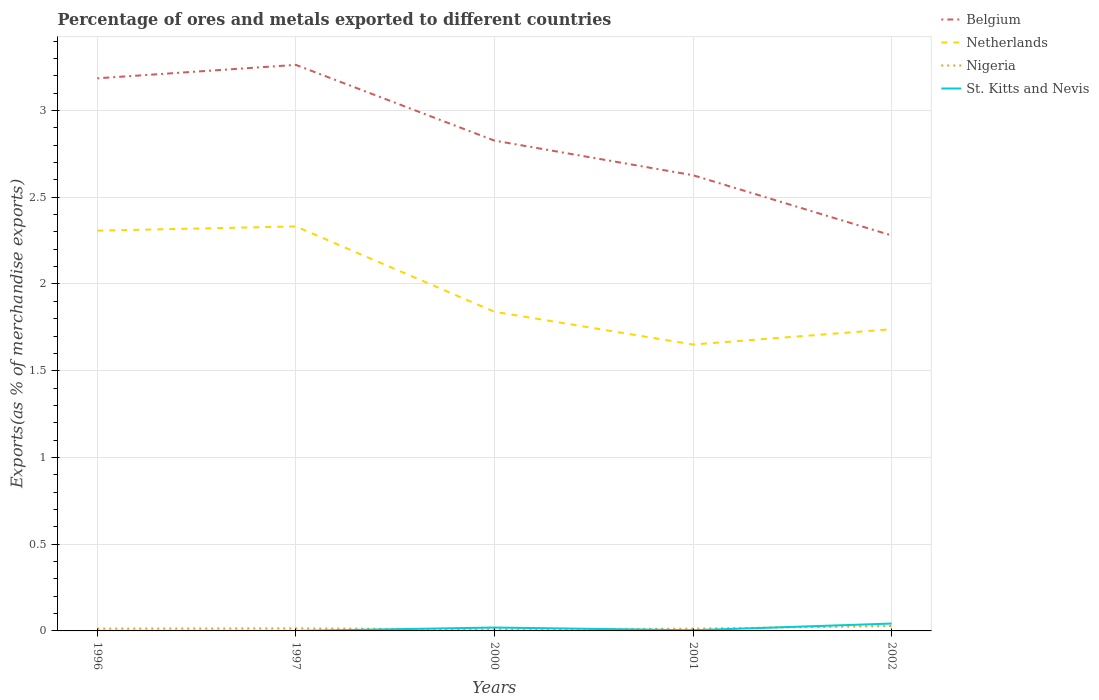Is the number of lines equal to the number of legend labels?
Offer a very short reply. Yes. Across all years, what is the maximum percentage of exports to different countries in Netherlands?
Your response must be concise. 1.65. What is the total percentage of exports to different countries in Nigeria in the graph?
Offer a terse response. -0.02. What is the difference between the highest and the second highest percentage of exports to different countries in St. Kitts and Nevis?
Give a very brief answer. 0.04. Is the percentage of exports to different countries in Netherlands strictly greater than the percentage of exports to different countries in St. Kitts and Nevis over the years?
Offer a very short reply. No. How many lines are there?
Provide a short and direct response. 4. What is the difference between two consecutive major ticks on the Y-axis?
Provide a short and direct response. 0.5. Are the values on the major ticks of Y-axis written in scientific E-notation?
Your response must be concise. No. Does the graph contain any zero values?
Ensure brevity in your answer.  No. Does the graph contain grids?
Make the answer very short. Yes. How many legend labels are there?
Keep it short and to the point. 4. How are the legend labels stacked?
Your response must be concise. Vertical. What is the title of the graph?
Make the answer very short. Percentage of ores and metals exported to different countries. What is the label or title of the Y-axis?
Provide a succinct answer. Exports(as % of merchandise exports). What is the Exports(as % of merchandise exports) in Belgium in 1996?
Your response must be concise. 3.19. What is the Exports(as % of merchandise exports) of Netherlands in 1996?
Keep it short and to the point. 2.31. What is the Exports(as % of merchandise exports) in Nigeria in 1996?
Give a very brief answer. 0.01. What is the Exports(as % of merchandise exports) in St. Kitts and Nevis in 1996?
Give a very brief answer. 0. What is the Exports(as % of merchandise exports) of Belgium in 1997?
Provide a succinct answer. 3.26. What is the Exports(as % of merchandise exports) of Netherlands in 1997?
Give a very brief answer. 2.33. What is the Exports(as % of merchandise exports) in Nigeria in 1997?
Provide a short and direct response. 0.01. What is the Exports(as % of merchandise exports) in St. Kitts and Nevis in 1997?
Your answer should be very brief. 0. What is the Exports(as % of merchandise exports) of Belgium in 2000?
Your response must be concise. 2.83. What is the Exports(as % of merchandise exports) of Netherlands in 2000?
Offer a very short reply. 1.84. What is the Exports(as % of merchandise exports) of Nigeria in 2000?
Provide a succinct answer. 0.01. What is the Exports(as % of merchandise exports) of St. Kitts and Nevis in 2000?
Give a very brief answer. 0.02. What is the Exports(as % of merchandise exports) of Belgium in 2001?
Ensure brevity in your answer.  2.63. What is the Exports(as % of merchandise exports) of Netherlands in 2001?
Provide a short and direct response. 1.65. What is the Exports(as % of merchandise exports) of Nigeria in 2001?
Give a very brief answer. 0.01. What is the Exports(as % of merchandise exports) of St. Kitts and Nevis in 2001?
Your response must be concise. 0. What is the Exports(as % of merchandise exports) in Belgium in 2002?
Your response must be concise. 2.28. What is the Exports(as % of merchandise exports) of Netherlands in 2002?
Ensure brevity in your answer.  1.74. What is the Exports(as % of merchandise exports) in Nigeria in 2002?
Provide a short and direct response. 0.03. What is the Exports(as % of merchandise exports) in St. Kitts and Nevis in 2002?
Your answer should be very brief. 0.04. Across all years, what is the maximum Exports(as % of merchandise exports) of Belgium?
Provide a succinct answer. 3.26. Across all years, what is the maximum Exports(as % of merchandise exports) of Netherlands?
Ensure brevity in your answer.  2.33. Across all years, what is the maximum Exports(as % of merchandise exports) of Nigeria?
Give a very brief answer. 0.03. Across all years, what is the maximum Exports(as % of merchandise exports) in St. Kitts and Nevis?
Provide a short and direct response. 0.04. Across all years, what is the minimum Exports(as % of merchandise exports) in Belgium?
Keep it short and to the point. 2.28. Across all years, what is the minimum Exports(as % of merchandise exports) of Netherlands?
Your answer should be very brief. 1.65. Across all years, what is the minimum Exports(as % of merchandise exports) in Nigeria?
Offer a very short reply. 0.01. Across all years, what is the minimum Exports(as % of merchandise exports) in St. Kitts and Nevis?
Provide a short and direct response. 0. What is the total Exports(as % of merchandise exports) in Belgium in the graph?
Provide a succinct answer. 14.18. What is the total Exports(as % of merchandise exports) of Netherlands in the graph?
Keep it short and to the point. 9.87. What is the total Exports(as % of merchandise exports) in Nigeria in the graph?
Provide a succinct answer. 0.08. What is the total Exports(as % of merchandise exports) in St. Kitts and Nevis in the graph?
Your response must be concise. 0.07. What is the difference between the Exports(as % of merchandise exports) in Belgium in 1996 and that in 1997?
Your answer should be very brief. -0.08. What is the difference between the Exports(as % of merchandise exports) of Netherlands in 1996 and that in 1997?
Your answer should be very brief. -0.02. What is the difference between the Exports(as % of merchandise exports) of Nigeria in 1996 and that in 1997?
Provide a short and direct response. -0. What is the difference between the Exports(as % of merchandise exports) of Belgium in 1996 and that in 2000?
Offer a very short reply. 0.36. What is the difference between the Exports(as % of merchandise exports) of Netherlands in 1996 and that in 2000?
Offer a terse response. 0.47. What is the difference between the Exports(as % of merchandise exports) of Nigeria in 1996 and that in 2000?
Your answer should be very brief. 0. What is the difference between the Exports(as % of merchandise exports) in St. Kitts and Nevis in 1996 and that in 2000?
Offer a terse response. -0.02. What is the difference between the Exports(as % of merchandise exports) of Belgium in 1996 and that in 2001?
Offer a terse response. 0.56. What is the difference between the Exports(as % of merchandise exports) in Netherlands in 1996 and that in 2001?
Offer a terse response. 0.66. What is the difference between the Exports(as % of merchandise exports) of Nigeria in 1996 and that in 2001?
Keep it short and to the point. 0. What is the difference between the Exports(as % of merchandise exports) of St. Kitts and Nevis in 1996 and that in 2001?
Your response must be concise. -0. What is the difference between the Exports(as % of merchandise exports) in Belgium in 1996 and that in 2002?
Provide a short and direct response. 0.91. What is the difference between the Exports(as % of merchandise exports) in Netherlands in 1996 and that in 2002?
Your response must be concise. 0.57. What is the difference between the Exports(as % of merchandise exports) in Nigeria in 1996 and that in 2002?
Give a very brief answer. -0.02. What is the difference between the Exports(as % of merchandise exports) in St. Kitts and Nevis in 1996 and that in 2002?
Your answer should be compact. -0.04. What is the difference between the Exports(as % of merchandise exports) of Belgium in 1997 and that in 2000?
Ensure brevity in your answer.  0.44. What is the difference between the Exports(as % of merchandise exports) in Netherlands in 1997 and that in 2000?
Make the answer very short. 0.49. What is the difference between the Exports(as % of merchandise exports) in Nigeria in 1997 and that in 2000?
Ensure brevity in your answer.  0.01. What is the difference between the Exports(as % of merchandise exports) in St. Kitts and Nevis in 1997 and that in 2000?
Offer a terse response. -0.02. What is the difference between the Exports(as % of merchandise exports) in Belgium in 1997 and that in 2001?
Ensure brevity in your answer.  0.64. What is the difference between the Exports(as % of merchandise exports) in Netherlands in 1997 and that in 2001?
Provide a succinct answer. 0.68. What is the difference between the Exports(as % of merchandise exports) of Nigeria in 1997 and that in 2001?
Your answer should be very brief. 0. What is the difference between the Exports(as % of merchandise exports) of St. Kitts and Nevis in 1997 and that in 2001?
Offer a terse response. -0. What is the difference between the Exports(as % of merchandise exports) of Belgium in 1997 and that in 2002?
Give a very brief answer. 0.98. What is the difference between the Exports(as % of merchandise exports) in Netherlands in 1997 and that in 2002?
Give a very brief answer. 0.59. What is the difference between the Exports(as % of merchandise exports) of Nigeria in 1997 and that in 2002?
Keep it short and to the point. -0.01. What is the difference between the Exports(as % of merchandise exports) in St. Kitts and Nevis in 1997 and that in 2002?
Offer a very short reply. -0.04. What is the difference between the Exports(as % of merchandise exports) of Belgium in 2000 and that in 2001?
Ensure brevity in your answer.  0.2. What is the difference between the Exports(as % of merchandise exports) in Netherlands in 2000 and that in 2001?
Provide a succinct answer. 0.19. What is the difference between the Exports(as % of merchandise exports) of Nigeria in 2000 and that in 2001?
Offer a terse response. -0. What is the difference between the Exports(as % of merchandise exports) of St. Kitts and Nevis in 2000 and that in 2001?
Provide a succinct answer. 0.02. What is the difference between the Exports(as % of merchandise exports) of Belgium in 2000 and that in 2002?
Provide a short and direct response. 0.55. What is the difference between the Exports(as % of merchandise exports) in Netherlands in 2000 and that in 2002?
Provide a succinct answer. 0.1. What is the difference between the Exports(as % of merchandise exports) in Nigeria in 2000 and that in 2002?
Your answer should be compact. -0.02. What is the difference between the Exports(as % of merchandise exports) in St. Kitts and Nevis in 2000 and that in 2002?
Provide a succinct answer. -0.02. What is the difference between the Exports(as % of merchandise exports) in Belgium in 2001 and that in 2002?
Make the answer very short. 0.35. What is the difference between the Exports(as % of merchandise exports) of Netherlands in 2001 and that in 2002?
Keep it short and to the point. -0.09. What is the difference between the Exports(as % of merchandise exports) of Nigeria in 2001 and that in 2002?
Your answer should be very brief. -0.02. What is the difference between the Exports(as % of merchandise exports) of St. Kitts and Nevis in 2001 and that in 2002?
Your answer should be compact. -0.04. What is the difference between the Exports(as % of merchandise exports) of Belgium in 1996 and the Exports(as % of merchandise exports) of Netherlands in 1997?
Offer a terse response. 0.85. What is the difference between the Exports(as % of merchandise exports) of Belgium in 1996 and the Exports(as % of merchandise exports) of Nigeria in 1997?
Your answer should be very brief. 3.17. What is the difference between the Exports(as % of merchandise exports) in Belgium in 1996 and the Exports(as % of merchandise exports) in St. Kitts and Nevis in 1997?
Offer a terse response. 3.19. What is the difference between the Exports(as % of merchandise exports) in Netherlands in 1996 and the Exports(as % of merchandise exports) in Nigeria in 1997?
Provide a short and direct response. 2.29. What is the difference between the Exports(as % of merchandise exports) of Netherlands in 1996 and the Exports(as % of merchandise exports) of St. Kitts and Nevis in 1997?
Your response must be concise. 2.31. What is the difference between the Exports(as % of merchandise exports) of Nigeria in 1996 and the Exports(as % of merchandise exports) of St. Kitts and Nevis in 1997?
Make the answer very short. 0.01. What is the difference between the Exports(as % of merchandise exports) of Belgium in 1996 and the Exports(as % of merchandise exports) of Netherlands in 2000?
Offer a very short reply. 1.35. What is the difference between the Exports(as % of merchandise exports) in Belgium in 1996 and the Exports(as % of merchandise exports) in Nigeria in 2000?
Your answer should be compact. 3.18. What is the difference between the Exports(as % of merchandise exports) of Belgium in 1996 and the Exports(as % of merchandise exports) of St. Kitts and Nevis in 2000?
Keep it short and to the point. 3.17. What is the difference between the Exports(as % of merchandise exports) of Netherlands in 1996 and the Exports(as % of merchandise exports) of Nigeria in 2000?
Make the answer very short. 2.3. What is the difference between the Exports(as % of merchandise exports) in Netherlands in 1996 and the Exports(as % of merchandise exports) in St. Kitts and Nevis in 2000?
Give a very brief answer. 2.29. What is the difference between the Exports(as % of merchandise exports) in Nigeria in 1996 and the Exports(as % of merchandise exports) in St. Kitts and Nevis in 2000?
Give a very brief answer. -0.01. What is the difference between the Exports(as % of merchandise exports) in Belgium in 1996 and the Exports(as % of merchandise exports) in Netherlands in 2001?
Give a very brief answer. 1.53. What is the difference between the Exports(as % of merchandise exports) of Belgium in 1996 and the Exports(as % of merchandise exports) of Nigeria in 2001?
Your answer should be compact. 3.17. What is the difference between the Exports(as % of merchandise exports) in Belgium in 1996 and the Exports(as % of merchandise exports) in St. Kitts and Nevis in 2001?
Your response must be concise. 3.18. What is the difference between the Exports(as % of merchandise exports) of Netherlands in 1996 and the Exports(as % of merchandise exports) of Nigeria in 2001?
Offer a terse response. 2.29. What is the difference between the Exports(as % of merchandise exports) in Netherlands in 1996 and the Exports(as % of merchandise exports) in St. Kitts and Nevis in 2001?
Provide a short and direct response. 2.3. What is the difference between the Exports(as % of merchandise exports) of Nigeria in 1996 and the Exports(as % of merchandise exports) of St. Kitts and Nevis in 2001?
Make the answer very short. 0.01. What is the difference between the Exports(as % of merchandise exports) of Belgium in 1996 and the Exports(as % of merchandise exports) of Netherlands in 2002?
Your answer should be very brief. 1.45. What is the difference between the Exports(as % of merchandise exports) of Belgium in 1996 and the Exports(as % of merchandise exports) of Nigeria in 2002?
Offer a terse response. 3.16. What is the difference between the Exports(as % of merchandise exports) of Belgium in 1996 and the Exports(as % of merchandise exports) of St. Kitts and Nevis in 2002?
Give a very brief answer. 3.14. What is the difference between the Exports(as % of merchandise exports) of Netherlands in 1996 and the Exports(as % of merchandise exports) of Nigeria in 2002?
Your response must be concise. 2.28. What is the difference between the Exports(as % of merchandise exports) in Netherlands in 1996 and the Exports(as % of merchandise exports) in St. Kitts and Nevis in 2002?
Offer a terse response. 2.26. What is the difference between the Exports(as % of merchandise exports) of Nigeria in 1996 and the Exports(as % of merchandise exports) of St. Kitts and Nevis in 2002?
Your answer should be compact. -0.03. What is the difference between the Exports(as % of merchandise exports) in Belgium in 1997 and the Exports(as % of merchandise exports) in Netherlands in 2000?
Offer a terse response. 1.42. What is the difference between the Exports(as % of merchandise exports) in Belgium in 1997 and the Exports(as % of merchandise exports) in Nigeria in 2000?
Provide a succinct answer. 3.25. What is the difference between the Exports(as % of merchandise exports) of Belgium in 1997 and the Exports(as % of merchandise exports) of St. Kitts and Nevis in 2000?
Provide a short and direct response. 3.24. What is the difference between the Exports(as % of merchandise exports) in Netherlands in 1997 and the Exports(as % of merchandise exports) in Nigeria in 2000?
Your answer should be compact. 2.32. What is the difference between the Exports(as % of merchandise exports) of Netherlands in 1997 and the Exports(as % of merchandise exports) of St. Kitts and Nevis in 2000?
Offer a terse response. 2.31. What is the difference between the Exports(as % of merchandise exports) in Nigeria in 1997 and the Exports(as % of merchandise exports) in St. Kitts and Nevis in 2000?
Ensure brevity in your answer.  -0. What is the difference between the Exports(as % of merchandise exports) of Belgium in 1997 and the Exports(as % of merchandise exports) of Netherlands in 2001?
Give a very brief answer. 1.61. What is the difference between the Exports(as % of merchandise exports) in Belgium in 1997 and the Exports(as % of merchandise exports) in Nigeria in 2001?
Your answer should be compact. 3.25. What is the difference between the Exports(as % of merchandise exports) in Belgium in 1997 and the Exports(as % of merchandise exports) in St. Kitts and Nevis in 2001?
Keep it short and to the point. 3.26. What is the difference between the Exports(as % of merchandise exports) in Netherlands in 1997 and the Exports(as % of merchandise exports) in Nigeria in 2001?
Your answer should be compact. 2.32. What is the difference between the Exports(as % of merchandise exports) in Netherlands in 1997 and the Exports(as % of merchandise exports) in St. Kitts and Nevis in 2001?
Offer a terse response. 2.33. What is the difference between the Exports(as % of merchandise exports) in Nigeria in 1997 and the Exports(as % of merchandise exports) in St. Kitts and Nevis in 2001?
Ensure brevity in your answer.  0.01. What is the difference between the Exports(as % of merchandise exports) of Belgium in 1997 and the Exports(as % of merchandise exports) of Netherlands in 2002?
Provide a short and direct response. 1.52. What is the difference between the Exports(as % of merchandise exports) in Belgium in 1997 and the Exports(as % of merchandise exports) in Nigeria in 2002?
Keep it short and to the point. 3.23. What is the difference between the Exports(as % of merchandise exports) in Belgium in 1997 and the Exports(as % of merchandise exports) in St. Kitts and Nevis in 2002?
Provide a succinct answer. 3.22. What is the difference between the Exports(as % of merchandise exports) in Netherlands in 1997 and the Exports(as % of merchandise exports) in Nigeria in 2002?
Make the answer very short. 2.3. What is the difference between the Exports(as % of merchandise exports) of Netherlands in 1997 and the Exports(as % of merchandise exports) of St. Kitts and Nevis in 2002?
Offer a very short reply. 2.29. What is the difference between the Exports(as % of merchandise exports) of Nigeria in 1997 and the Exports(as % of merchandise exports) of St. Kitts and Nevis in 2002?
Provide a succinct answer. -0.03. What is the difference between the Exports(as % of merchandise exports) of Belgium in 2000 and the Exports(as % of merchandise exports) of Netherlands in 2001?
Your answer should be compact. 1.18. What is the difference between the Exports(as % of merchandise exports) in Belgium in 2000 and the Exports(as % of merchandise exports) in Nigeria in 2001?
Give a very brief answer. 2.81. What is the difference between the Exports(as % of merchandise exports) in Belgium in 2000 and the Exports(as % of merchandise exports) in St. Kitts and Nevis in 2001?
Provide a short and direct response. 2.82. What is the difference between the Exports(as % of merchandise exports) in Netherlands in 2000 and the Exports(as % of merchandise exports) in Nigeria in 2001?
Offer a terse response. 1.83. What is the difference between the Exports(as % of merchandise exports) in Netherlands in 2000 and the Exports(as % of merchandise exports) in St. Kitts and Nevis in 2001?
Your response must be concise. 1.84. What is the difference between the Exports(as % of merchandise exports) of Nigeria in 2000 and the Exports(as % of merchandise exports) of St. Kitts and Nevis in 2001?
Your answer should be very brief. 0. What is the difference between the Exports(as % of merchandise exports) in Belgium in 2000 and the Exports(as % of merchandise exports) in Netherlands in 2002?
Make the answer very short. 1.09. What is the difference between the Exports(as % of merchandise exports) in Belgium in 2000 and the Exports(as % of merchandise exports) in Nigeria in 2002?
Your answer should be compact. 2.8. What is the difference between the Exports(as % of merchandise exports) of Belgium in 2000 and the Exports(as % of merchandise exports) of St. Kitts and Nevis in 2002?
Offer a very short reply. 2.78. What is the difference between the Exports(as % of merchandise exports) of Netherlands in 2000 and the Exports(as % of merchandise exports) of Nigeria in 2002?
Your answer should be compact. 1.81. What is the difference between the Exports(as % of merchandise exports) of Netherlands in 2000 and the Exports(as % of merchandise exports) of St. Kitts and Nevis in 2002?
Provide a short and direct response. 1.8. What is the difference between the Exports(as % of merchandise exports) in Nigeria in 2000 and the Exports(as % of merchandise exports) in St. Kitts and Nevis in 2002?
Provide a succinct answer. -0.03. What is the difference between the Exports(as % of merchandise exports) in Belgium in 2001 and the Exports(as % of merchandise exports) in Netherlands in 2002?
Ensure brevity in your answer.  0.89. What is the difference between the Exports(as % of merchandise exports) in Belgium in 2001 and the Exports(as % of merchandise exports) in Nigeria in 2002?
Provide a succinct answer. 2.6. What is the difference between the Exports(as % of merchandise exports) of Belgium in 2001 and the Exports(as % of merchandise exports) of St. Kitts and Nevis in 2002?
Ensure brevity in your answer.  2.58. What is the difference between the Exports(as % of merchandise exports) of Netherlands in 2001 and the Exports(as % of merchandise exports) of Nigeria in 2002?
Provide a short and direct response. 1.62. What is the difference between the Exports(as % of merchandise exports) of Netherlands in 2001 and the Exports(as % of merchandise exports) of St. Kitts and Nevis in 2002?
Give a very brief answer. 1.61. What is the difference between the Exports(as % of merchandise exports) of Nigeria in 2001 and the Exports(as % of merchandise exports) of St. Kitts and Nevis in 2002?
Offer a very short reply. -0.03. What is the average Exports(as % of merchandise exports) of Belgium per year?
Your answer should be compact. 2.84. What is the average Exports(as % of merchandise exports) of Netherlands per year?
Provide a short and direct response. 1.97. What is the average Exports(as % of merchandise exports) of Nigeria per year?
Your response must be concise. 0.02. What is the average Exports(as % of merchandise exports) in St. Kitts and Nevis per year?
Your answer should be very brief. 0.01. In the year 1996, what is the difference between the Exports(as % of merchandise exports) of Belgium and Exports(as % of merchandise exports) of Netherlands?
Offer a very short reply. 0.88. In the year 1996, what is the difference between the Exports(as % of merchandise exports) in Belgium and Exports(as % of merchandise exports) in Nigeria?
Offer a very short reply. 3.17. In the year 1996, what is the difference between the Exports(as % of merchandise exports) of Belgium and Exports(as % of merchandise exports) of St. Kitts and Nevis?
Your answer should be very brief. 3.19. In the year 1996, what is the difference between the Exports(as % of merchandise exports) of Netherlands and Exports(as % of merchandise exports) of Nigeria?
Provide a succinct answer. 2.29. In the year 1996, what is the difference between the Exports(as % of merchandise exports) in Netherlands and Exports(as % of merchandise exports) in St. Kitts and Nevis?
Your answer should be very brief. 2.31. In the year 1996, what is the difference between the Exports(as % of merchandise exports) of Nigeria and Exports(as % of merchandise exports) of St. Kitts and Nevis?
Provide a short and direct response. 0.01. In the year 1997, what is the difference between the Exports(as % of merchandise exports) of Belgium and Exports(as % of merchandise exports) of Netherlands?
Offer a very short reply. 0.93. In the year 1997, what is the difference between the Exports(as % of merchandise exports) of Belgium and Exports(as % of merchandise exports) of Nigeria?
Offer a very short reply. 3.25. In the year 1997, what is the difference between the Exports(as % of merchandise exports) of Belgium and Exports(as % of merchandise exports) of St. Kitts and Nevis?
Give a very brief answer. 3.26. In the year 1997, what is the difference between the Exports(as % of merchandise exports) of Netherlands and Exports(as % of merchandise exports) of Nigeria?
Offer a terse response. 2.32. In the year 1997, what is the difference between the Exports(as % of merchandise exports) of Netherlands and Exports(as % of merchandise exports) of St. Kitts and Nevis?
Offer a very short reply. 2.33. In the year 1997, what is the difference between the Exports(as % of merchandise exports) of Nigeria and Exports(as % of merchandise exports) of St. Kitts and Nevis?
Give a very brief answer. 0.01. In the year 2000, what is the difference between the Exports(as % of merchandise exports) of Belgium and Exports(as % of merchandise exports) of Netherlands?
Your response must be concise. 0.99. In the year 2000, what is the difference between the Exports(as % of merchandise exports) of Belgium and Exports(as % of merchandise exports) of Nigeria?
Offer a very short reply. 2.82. In the year 2000, what is the difference between the Exports(as % of merchandise exports) of Belgium and Exports(as % of merchandise exports) of St. Kitts and Nevis?
Give a very brief answer. 2.81. In the year 2000, what is the difference between the Exports(as % of merchandise exports) in Netherlands and Exports(as % of merchandise exports) in Nigeria?
Your answer should be very brief. 1.83. In the year 2000, what is the difference between the Exports(as % of merchandise exports) in Netherlands and Exports(as % of merchandise exports) in St. Kitts and Nevis?
Provide a succinct answer. 1.82. In the year 2000, what is the difference between the Exports(as % of merchandise exports) of Nigeria and Exports(as % of merchandise exports) of St. Kitts and Nevis?
Offer a very short reply. -0.01. In the year 2001, what is the difference between the Exports(as % of merchandise exports) of Belgium and Exports(as % of merchandise exports) of Netherlands?
Your answer should be compact. 0.98. In the year 2001, what is the difference between the Exports(as % of merchandise exports) in Belgium and Exports(as % of merchandise exports) in Nigeria?
Keep it short and to the point. 2.61. In the year 2001, what is the difference between the Exports(as % of merchandise exports) of Belgium and Exports(as % of merchandise exports) of St. Kitts and Nevis?
Keep it short and to the point. 2.62. In the year 2001, what is the difference between the Exports(as % of merchandise exports) of Netherlands and Exports(as % of merchandise exports) of Nigeria?
Your answer should be compact. 1.64. In the year 2001, what is the difference between the Exports(as % of merchandise exports) of Netherlands and Exports(as % of merchandise exports) of St. Kitts and Nevis?
Your answer should be compact. 1.65. In the year 2001, what is the difference between the Exports(as % of merchandise exports) in Nigeria and Exports(as % of merchandise exports) in St. Kitts and Nevis?
Make the answer very short. 0.01. In the year 2002, what is the difference between the Exports(as % of merchandise exports) in Belgium and Exports(as % of merchandise exports) in Netherlands?
Ensure brevity in your answer.  0.54. In the year 2002, what is the difference between the Exports(as % of merchandise exports) in Belgium and Exports(as % of merchandise exports) in Nigeria?
Give a very brief answer. 2.25. In the year 2002, what is the difference between the Exports(as % of merchandise exports) of Belgium and Exports(as % of merchandise exports) of St. Kitts and Nevis?
Offer a terse response. 2.24. In the year 2002, what is the difference between the Exports(as % of merchandise exports) in Netherlands and Exports(as % of merchandise exports) in Nigeria?
Give a very brief answer. 1.71. In the year 2002, what is the difference between the Exports(as % of merchandise exports) in Netherlands and Exports(as % of merchandise exports) in St. Kitts and Nevis?
Offer a terse response. 1.7. In the year 2002, what is the difference between the Exports(as % of merchandise exports) in Nigeria and Exports(as % of merchandise exports) in St. Kitts and Nevis?
Offer a very short reply. -0.01. What is the ratio of the Exports(as % of merchandise exports) of Belgium in 1996 to that in 1997?
Offer a very short reply. 0.98. What is the ratio of the Exports(as % of merchandise exports) of Netherlands in 1996 to that in 1997?
Provide a succinct answer. 0.99. What is the ratio of the Exports(as % of merchandise exports) in Nigeria in 1996 to that in 1997?
Give a very brief answer. 0.92. What is the ratio of the Exports(as % of merchandise exports) in St. Kitts and Nevis in 1996 to that in 1997?
Provide a short and direct response. 1.55. What is the ratio of the Exports(as % of merchandise exports) of Belgium in 1996 to that in 2000?
Your answer should be compact. 1.13. What is the ratio of the Exports(as % of merchandise exports) in Netherlands in 1996 to that in 2000?
Your answer should be compact. 1.25. What is the ratio of the Exports(as % of merchandise exports) of Nigeria in 1996 to that in 2000?
Your response must be concise. 1.54. What is the ratio of the Exports(as % of merchandise exports) in St. Kitts and Nevis in 1996 to that in 2000?
Keep it short and to the point. 0.01. What is the ratio of the Exports(as % of merchandise exports) in Belgium in 1996 to that in 2001?
Provide a succinct answer. 1.21. What is the ratio of the Exports(as % of merchandise exports) of Netherlands in 1996 to that in 2001?
Offer a terse response. 1.4. What is the ratio of the Exports(as % of merchandise exports) in Nigeria in 1996 to that in 2001?
Keep it short and to the point. 1.05. What is the ratio of the Exports(as % of merchandise exports) of St. Kitts and Nevis in 1996 to that in 2001?
Provide a succinct answer. 0.06. What is the ratio of the Exports(as % of merchandise exports) of Belgium in 1996 to that in 2002?
Your answer should be compact. 1.4. What is the ratio of the Exports(as % of merchandise exports) of Netherlands in 1996 to that in 2002?
Offer a terse response. 1.33. What is the ratio of the Exports(as % of merchandise exports) in Nigeria in 1996 to that in 2002?
Your answer should be compact. 0.47. What is the ratio of the Exports(as % of merchandise exports) in St. Kitts and Nevis in 1996 to that in 2002?
Provide a short and direct response. 0.01. What is the ratio of the Exports(as % of merchandise exports) of Belgium in 1997 to that in 2000?
Keep it short and to the point. 1.15. What is the ratio of the Exports(as % of merchandise exports) in Netherlands in 1997 to that in 2000?
Provide a short and direct response. 1.27. What is the ratio of the Exports(as % of merchandise exports) in Nigeria in 1997 to that in 2000?
Keep it short and to the point. 1.68. What is the ratio of the Exports(as % of merchandise exports) of St. Kitts and Nevis in 1997 to that in 2000?
Offer a very short reply. 0.01. What is the ratio of the Exports(as % of merchandise exports) of Belgium in 1997 to that in 2001?
Provide a short and direct response. 1.24. What is the ratio of the Exports(as % of merchandise exports) of Netherlands in 1997 to that in 2001?
Offer a terse response. 1.41. What is the ratio of the Exports(as % of merchandise exports) of Nigeria in 1997 to that in 2001?
Ensure brevity in your answer.  1.15. What is the ratio of the Exports(as % of merchandise exports) of St. Kitts and Nevis in 1997 to that in 2001?
Provide a short and direct response. 0.04. What is the ratio of the Exports(as % of merchandise exports) of Belgium in 1997 to that in 2002?
Offer a terse response. 1.43. What is the ratio of the Exports(as % of merchandise exports) in Netherlands in 1997 to that in 2002?
Provide a short and direct response. 1.34. What is the ratio of the Exports(as % of merchandise exports) of Nigeria in 1997 to that in 2002?
Your response must be concise. 0.51. What is the ratio of the Exports(as % of merchandise exports) in St. Kitts and Nevis in 1997 to that in 2002?
Give a very brief answer. 0. What is the ratio of the Exports(as % of merchandise exports) in Belgium in 2000 to that in 2001?
Provide a succinct answer. 1.08. What is the ratio of the Exports(as % of merchandise exports) of Netherlands in 2000 to that in 2001?
Offer a very short reply. 1.11. What is the ratio of the Exports(as % of merchandise exports) of Nigeria in 2000 to that in 2001?
Offer a terse response. 0.68. What is the ratio of the Exports(as % of merchandise exports) of St. Kitts and Nevis in 2000 to that in 2001?
Offer a very short reply. 4.93. What is the ratio of the Exports(as % of merchandise exports) of Belgium in 2000 to that in 2002?
Ensure brevity in your answer.  1.24. What is the ratio of the Exports(as % of merchandise exports) in Netherlands in 2000 to that in 2002?
Your response must be concise. 1.06. What is the ratio of the Exports(as % of merchandise exports) of Nigeria in 2000 to that in 2002?
Make the answer very short. 0.31. What is the ratio of the Exports(as % of merchandise exports) of St. Kitts and Nevis in 2000 to that in 2002?
Your response must be concise. 0.46. What is the ratio of the Exports(as % of merchandise exports) in Belgium in 2001 to that in 2002?
Your answer should be very brief. 1.15. What is the ratio of the Exports(as % of merchandise exports) of Netherlands in 2001 to that in 2002?
Provide a succinct answer. 0.95. What is the ratio of the Exports(as % of merchandise exports) of Nigeria in 2001 to that in 2002?
Your answer should be compact. 0.45. What is the ratio of the Exports(as % of merchandise exports) of St. Kitts and Nevis in 2001 to that in 2002?
Offer a very short reply. 0.09. What is the difference between the highest and the second highest Exports(as % of merchandise exports) in Belgium?
Offer a very short reply. 0.08. What is the difference between the highest and the second highest Exports(as % of merchandise exports) in Netherlands?
Provide a short and direct response. 0.02. What is the difference between the highest and the second highest Exports(as % of merchandise exports) of Nigeria?
Provide a succinct answer. 0.01. What is the difference between the highest and the second highest Exports(as % of merchandise exports) of St. Kitts and Nevis?
Provide a short and direct response. 0.02. What is the difference between the highest and the lowest Exports(as % of merchandise exports) in Belgium?
Your response must be concise. 0.98. What is the difference between the highest and the lowest Exports(as % of merchandise exports) of Netherlands?
Your answer should be very brief. 0.68. What is the difference between the highest and the lowest Exports(as % of merchandise exports) of Nigeria?
Your response must be concise. 0.02. What is the difference between the highest and the lowest Exports(as % of merchandise exports) in St. Kitts and Nevis?
Your answer should be compact. 0.04. 